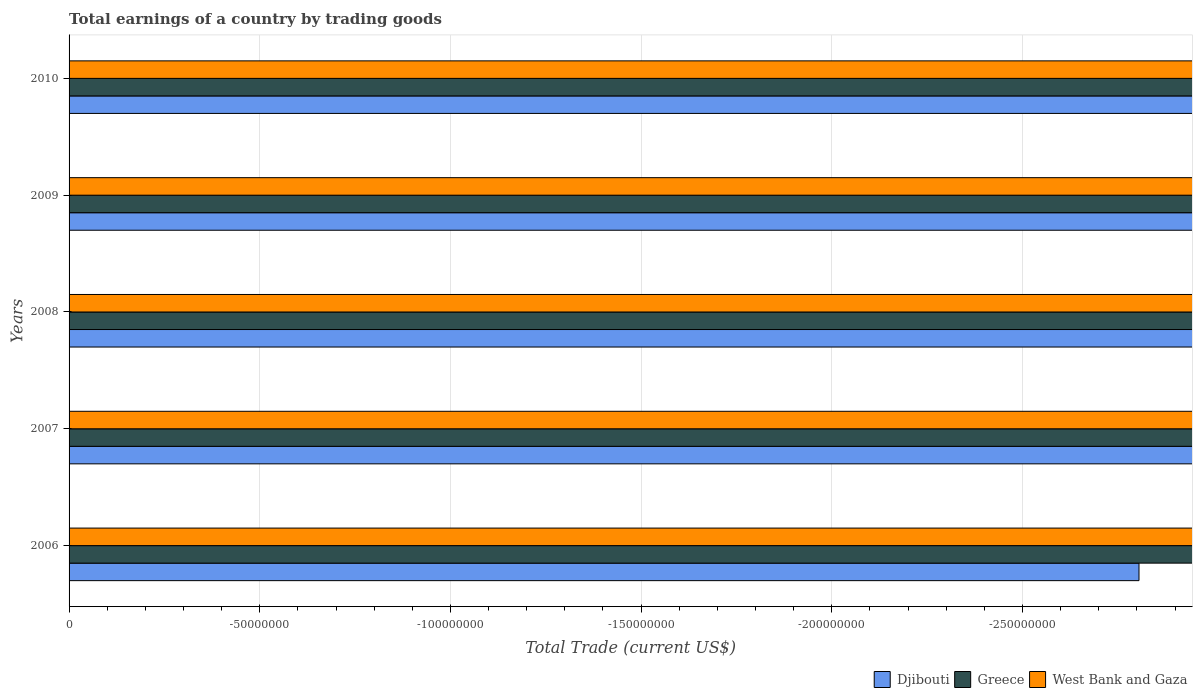How many different coloured bars are there?
Provide a succinct answer. 0. Are the number of bars per tick equal to the number of legend labels?
Give a very brief answer. No. Are the number of bars on each tick of the Y-axis equal?
Provide a short and direct response. Yes. What is the label of the 3rd group of bars from the top?
Make the answer very short. 2008. What is the total earnings in West Bank and Gaza in 2006?
Make the answer very short. 0. Across all years, what is the minimum total earnings in Greece?
Make the answer very short. 0. In how many years, is the total earnings in Greece greater than -160000000 US$?
Your answer should be very brief. 0. In how many years, is the total earnings in Djibouti greater than the average total earnings in Djibouti taken over all years?
Give a very brief answer. 0. Is it the case that in every year, the sum of the total earnings in Greece and total earnings in Djibouti is greater than the total earnings in West Bank and Gaza?
Provide a short and direct response. No. How many years are there in the graph?
Make the answer very short. 5. Are the values on the major ticks of X-axis written in scientific E-notation?
Your answer should be compact. No. Does the graph contain any zero values?
Make the answer very short. Yes. Does the graph contain grids?
Offer a terse response. Yes. Where does the legend appear in the graph?
Your answer should be compact. Bottom right. How are the legend labels stacked?
Provide a short and direct response. Horizontal. What is the title of the graph?
Make the answer very short. Total earnings of a country by trading goods. What is the label or title of the X-axis?
Provide a succinct answer. Total Trade (current US$). What is the Total Trade (current US$) in Greece in 2006?
Ensure brevity in your answer.  0. What is the Total Trade (current US$) of Djibouti in 2008?
Make the answer very short. 0. What is the Total Trade (current US$) in Greece in 2009?
Offer a very short reply. 0. What is the Total Trade (current US$) in Djibouti in 2010?
Give a very brief answer. 0. What is the Total Trade (current US$) of Greece in 2010?
Make the answer very short. 0. What is the total Total Trade (current US$) of Greece in the graph?
Give a very brief answer. 0. What is the total Total Trade (current US$) of West Bank and Gaza in the graph?
Make the answer very short. 0. What is the average Total Trade (current US$) of Greece per year?
Offer a terse response. 0. What is the average Total Trade (current US$) in West Bank and Gaza per year?
Provide a short and direct response. 0. 